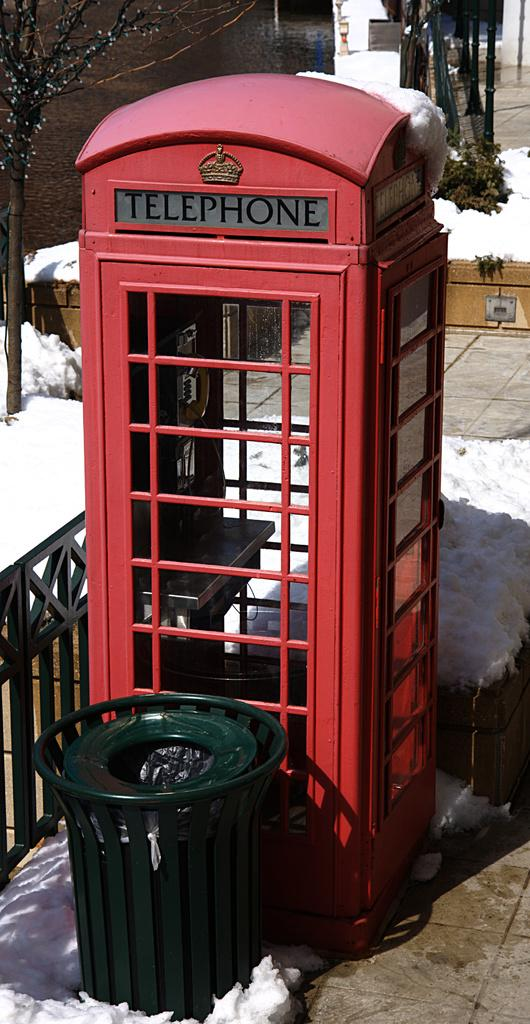<image>
Provide a brief description of the given image. A red telephone booth behind a green trash barrel, surrounded by snow on the ground. 